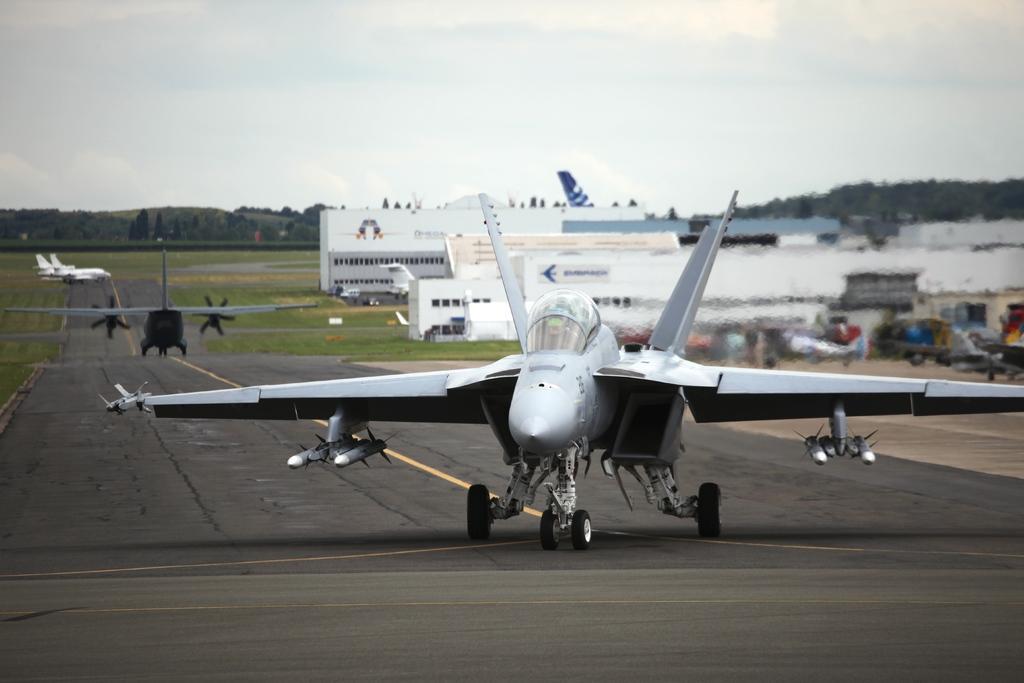In one or two sentences, can you explain what this image depicts? In this image there are aircraft on a runway, in the background there are building, trees, mountain and the sky and it is blurred. 